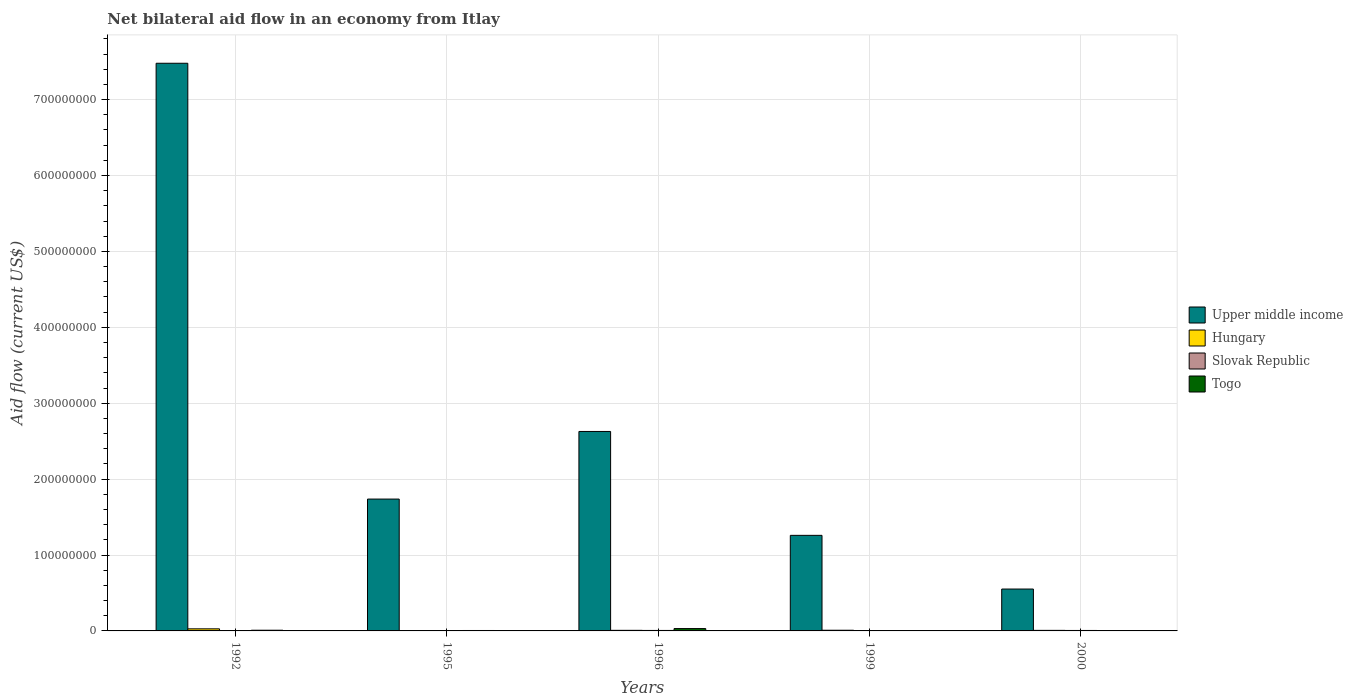How many different coloured bars are there?
Provide a succinct answer. 4. How many groups of bars are there?
Your response must be concise. 5. Are the number of bars per tick equal to the number of legend labels?
Provide a short and direct response. Yes. Are the number of bars on each tick of the X-axis equal?
Your response must be concise. Yes. How many bars are there on the 1st tick from the left?
Your answer should be compact. 4. How many bars are there on the 4th tick from the right?
Make the answer very short. 4. In how many cases, is the number of bars for a given year not equal to the number of legend labels?
Make the answer very short. 0. What is the net bilateral aid flow in Upper middle income in 2000?
Ensure brevity in your answer.  5.52e+07. Across all years, what is the maximum net bilateral aid flow in Slovak Republic?
Your answer should be compact. 6.30e+05. Across all years, what is the minimum net bilateral aid flow in Slovak Republic?
Make the answer very short. 2.50e+05. In which year was the net bilateral aid flow in Slovak Republic minimum?
Ensure brevity in your answer.  1995. What is the total net bilateral aid flow in Upper middle income in the graph?
Offer a very short reply. 1.37e+09. What is the difference between the net bilateral aid flow in Hungary in 1996 and that in 1999?
Ensure brevity in your answer.  -1.20e+05. What is the difference between the net bilateral aid flow in Togo in 1992 and the net bilateral aid flow in Hungary in 1999?
Give a very brief answer. 2.00e+04. What is the average net bilateral aid flow in Togo per year?
Make the answer very short. 9.20e+05. In how many years, is the net bilateral aid flow in Togo greater than 640000000 US$?
Your answer should be compact. 0. What is the ratio of the net bilateral aid flow in Upper middle income in 1996 to that in 1999?
Keep it short and to the point. 2.09. Is the net bilateral aid flow in Hungary in 1996 less than that in 2000?
Ensure brevity in your answer.  No. What is the difference between the highest and the lowest net bilateral aid flow in Togo?
Offer a terse response. 3.09e+06. In how many years, is the net bilateral aid flow in Togo greater than the average net bilateral aid flow in Togo taken over all years?
Make the answer very short. 1. Is it the case that in every year, the sum of the net bilateral aid flow in Togo and net bilateral aid flow in Hungary is greater than the sum of net bilateral aid flow in Slovak Republic and net bilateral aid flow in Upper middle income?
Offer a very short reply. No. What does the 2nd bar from the left in 1999 represents?
Your answer should be compact. Hungary. What does the 3rd bar from the right in 1999 represents?
Your response must be concise. Hungary. How many bars are there?
Make the answer very short. 20. How many years are there in the graph?
Your answer should be very brief. 5. Does the graph contain any zero values?
Keep it short and to the point. No. What is the title of the graph?
Provide a succinct answer. Net bilateral aid flow in an economy from Itlay. Does "Maldives" appear as one of the legend labels in the graph?
Your answer should be very brief. No. What is the label or title of the X-axis?
Provide a short and direct response. Years. What is the label or title of the Y-axis?
Give a very brief answer. Aid flow (current US$). What is the Aid flow (current US$) of Upper middle income in 1992?
Offer a terse response. 7.48e+08. What is the Aid flow (current US$) of Hungary in 1992?
Offer a very short reply. 2.74e+06. What is the Aid flow (current US$) of Slovak Republic in 1992?
Make the answer very short. 4.10e+05. What is the Aid flow (current US$) in Togo in 1992?
Give a very brief answer. 9.10e+05. What is the Aid flow (current US$) of Upper middle income in 1995?
Your answer should be very brief. 1.74e+08. What is the Aid flow (current US$) in Hungary in 1995?
Offer a very short reply. 3.30e+05. What is the Aid flow (current US$) of Togo in 1995?
Your answer should be compact. 5.70e+05. What is the Aid flow (current US$) in Upper middle income in 1996?
Provide a succinct answer. 2.63e+08. What is the Aid flow (current US$) of Hungary in 1996?
Your answer should be very brief. 7.70e+05. What is the Aid flow (current US$) of Slovak Republic in 1996?
Offer a very short reply. 6.30e+05. What is the Aid flow (current US$) in Togo in 1996?
Provide a succinct answer. 3.10e+06. What is the Aid flow (current US$) in Upper middle income in 1999?
Keep it short and to the point. 1.26e+08. What is the Aid flow (current US$) in Hungary in 1999?
Keep it short and to the point. 8.90e+05. What is the Aid flow (current US$) of Slovak Republic in 1999?
Ensure brevity in your answer.  2.60e+05. What is the Aid flow (current US$) in Upper middle income in 2000?
Provide a succinct answer. 5.52e+07. What is the Aid flow (current US$) in Hungary in 2000?
Ensure brevity in your answer.  7.20e+05. What is the Aid flow (current US$) of Slovak Republic in 2000?
Make the answer very short. 6.10e+05. Across all years, what is the maximum Aid flow (current US$) of Upper middle income?
Make the answer very short. 7.48e+08. Across all years, what is the maximum Aid flow (current US$) of Hungary?
Make the answer very short. 2.74e+06. Across all years, what is the maximum Aid flow (current US$) of Slovak Republic?
Your response must be concise. 6.30e+05. Across all years, what is the maximum Aid flow (current US$) in Togo?
Offer a very short reply. 3.10e+06. Across all years, what is the minimum Aid flow (current US$) of Upper middle income?
Ensure brevity in your answer.  5.52e+07. Across all years, what is the minimum Aid flow (current US$) of Hungary?
Ensure brevity in your answer.  3.30e+05. What is the total Aid flow (current US$) of Upper middle income in the graph?
Your answer should be compact. 1.37e+09. What is the total Aid flow (current US$) of Hungary in the graph?
Ensure brevity in your answer.  5.45e+06. What is the total Aid flow (current US$) of Slovak Republic in the graph?
Make the answer very short. 2.16e+06. What is the total Aid flow (current US$) of Togo in the graph?
Your answer should be very brief. 4.60e+06. What is the difference between the Aid flow (current US$) in Upper middle income in 1992 and that in 1995?
Your answer should be very brief. 5.74e+08. What is the difference between the Aid flow (current US$) in Hungary in 1992 and that in 1995?
Give a very brief answer. 2.41e+06. What is the difference between the Aid flow (current US$) of Slovak Republic in 1992 and that in 1995?
Make the answer very short. 1.60e+05. What is the difference between the Aid flow (current US$) of Togo in 1992 and that in 1995?
Your response must be concise. 3.40e+05. What is the difference between the Aid flow (current US$) of Upper middle income in 1992 and that in 1996?
Your answer should be compact. 4.85e+08. What is the difference between the Aid flow (current US$) of Hungary in 1992 and that in 1996?
Provide a succinct answer. 1.97e+06. What is the difference between the Aid flow (current US$) of Togo in 1992 and that in 1996?
Offer a very short reply. -2.19e+06. What is the difference between the Aid flow (current US$) in Upper middle income in 1992 and that in 1999?
Give a very brief answer. 6.22e+08. What is the difference between the Aid flow (current US$) of Hungary in 1992 and that in 1999?
Provide a succinct answer. 1.85e+06. What is the difference between the Aid flow (current US$) in Upper middle income in 1992 and that in 2000?
Your answer should be very brief. 6.93e+08. What is the difference between the Aid flow (current US$) in Hungary in 1992 and that in 2000?
Ensure brevity in your answer.  2.02e+06. What is the difference between the Aid flow (current US$) of Togo in 1992 and that in 2000?
Your response must be concise. 9.00e+05. What is the difference between the Aid flow (current US$) in Upper middle income in 1995 and that in 1996?
Your response must be concise. -8.91e+07. What is the difference between the Aid flow (current US$) of Hungary in 1995 and that in 1996?
Your answer should be compact. -4.40e+05. What is the difference between the Aid flow (current US$) of Slovak Republic in 1995 and that in 1996?
Ensure brevity in your answer.  -3.80e+05. What is the difference between the Aid flow (current US$) in Togo in 1995 and that in 1996?
Your response must be concise. -2.53e+06. What is the difference between the Aid flow (current US$) in Upper middle income in 1995 and that in 1999?
Your response must be concise. 4.78e+07. What is the difference between the Aid flow (current US$) of Hungary in 1995 and that in 1999?
Your response must be concise. -5.60e+05. What is the difference between the Aid flow (current US$) of Togo in 1995 and that in 1999?
Provide a succinct answer. 5.60e+05. What is the difference between the Aid flow (current US$) of Upper middle income in 1995 and that in 2000?
Provide a short and direct response. 1.19e+08. What is the difference between the Aid flow (current US$) of Hungary in 1995 and that in 2000?
Provide a succinct answer. -3.90e+05. What is the difference between the Aid flow (current US$) of Slovak Republic in 1995 and that in 2000?
Ensure brevity in your answer.  -3.60e+05. What is the difference between the Aid flow (current US$) in Togo in 1995 and that in 2000?
Ensure brevity in your answer.  5.60e+05. What is the difference between the Aid flow (current US$) of Upper middle income in 1996 and that in 1999?
Provide a succinct answer. 1.37e+08. What is the difference between the Aid flow (current US$) of Hungary in 1996 and that in 1999?
Ensure brevity in your answer.  -1.20e+05. What is the difference between the Aid flow (current US$) in Slovak Republic in 1996 and that in 1999?
Make the answer very short. 3.70e+05. What is the difference between the Aid flow (current US$) in Togo in 1996 and that in 1999?
Provide a succinct answer. 3.09e+06. What is the difference between the Aid flow (current US$) of Upper middle income in 1996 and that in 2000?
Your response must be concise. 2.08e+08. What is the difference between the Aid flow (current US$) in Hungary in 1996 and that in 2000?
Your answer should be compact. 5.00e+04. What is the difference between the Aid flow (current US$) of Slovak Republic in 1996 and that in 2000?
Your response must be concise. 2.00e+04. What is the difference between the Aid flow (current US$) of Togo in 1996 and that in 2000?
Your answer should be very brief. 3.09e+06. What is the difference between the Aid flow (current US$) of Upper middle income in 1999 and that in 2000?
Give a very brief answer. 7.07e+07. What is the difference between the Aid flow (current US$) in Slovak Republic in 1999 and that in 2000?
Offer a very short reply. -3.50e+05. What is the difference between the Aid flow (current US$) of Togo in 1999 and that in 2000?
Ensure brevity in your answer.  0. What is the difference between the Aid flow (current US$) of Upper middle income in 1992 and the Aid flow (current US$) of Hungary in 1995?
Ensure brevity in your answer.  7.48e+08. What is the difference between the Aid flow (current US$) in Upper middle income in 1992 and the Aid flow (current US$) in Slovak Republic in 1995?
Keep it short and to the point. 7.48e+08. What is the difference between the Aid flow (current US$) of Upper middle income in 1992 and the Aid flow (current US$) of Togo in 1995?
Offer a terse response. 7.47e+08. What is the difference between the Aid flow (current US$) in Hungary in 1992 and the Aid flow (current US$) in Slovak Republic in 1995?
Offer a very short reply. 2.49e+06. What is the difference between the Aid flow (current US$) in Hungary in 1992 and the Aid flow (current US$) in Togo in 1995?
Offer a very short reply. 2.17e+06. What is the difference between the Aid flow (current US$) of Upper middle income in 1992 and the Aid flow (current US$) of Hungary in 1996?
Make the answer very short. 7.47e+08. What is the difference between the Aid flow (current US$) of Upper middle income in 1992 and the Aid flow (current US$) of Slovak Republic in 1996?
Provide a short and direct response. 7.47e+08. What is the difference between the Aid flow (current US$) of Upper middle income in 1992 and the Aid flow (current US$) of Togo in 1996?
Offer a terse response. 7.45e+08. What is the difference between the Aid flow (current US$) in Hungary in 1992 and the Aid flow (current US$) in Slovak Republic in 1996?
Make the answer very short. 2.11e+06. What is the difference between the Aid flow (current US$) in Hungary in 1992 and the Aid flow (current US$) in Togo in 1996?
Ensure brevity in your answer.  -3.60e+05. What is the difference between the Aid flow (current US$) in Slovak Republic in 1992 and the Aid flow (current US$) in Togo in 1996?
Keep it short and to the point. -2.69e+06. What is the difference between the Aid flow (current US$) of Upper middle income in 1992 and the Aid flow (current US$) of Hungary in 1999?
Ensure brevity in your answer.  7.47e+08. What is the difference between the Aid flow (current US$) in Upper middle income in 1992 and the Aid flow (current US$) in Slovak Republic in 1999?
Make the answer very short. 7.48e+08. What is the difference between the Aid flow (current US$) of Upper middle income in 1992 and the Aid flow (current US$) of Togo in 1999?
Make the answer very short. 7.48e+08. What is the difference between the Aid flow (current US$) in Hungary in 1992 and the Aid flow (current US$) in Slovak Republic in 1999?
Offer a very short reply. 2.48e+06. What is the difference between the Aid flow (current US$) in Hungary in 1992 and the Aid flow (current US$) in Togo in 1999?
Your answer should be very brief. 2.73e+06. What is the difference between the Aid flow (current US$) in Upper middle income in 1992 and the Aid flow (current US$) in Hungary in 2000?
Ensure brevity in your answer.  7.47e+08. What is the difference between the Aid flow (current US$) in Upper middle income in 1992 and the Aid flow (current US$) in Slovak Republic in 2000?
Your answer should be compact. 7.47e+08. What is the difference between the Aid flow (current US$) in Upper middle income in 1992 and the Aid flow (current US$) in Togo in 2000?
Your answer should be compact. 7.48e+08. What is the difference between the Aid flow (current US$) of Hungary in 1992 and the Aid flow (current US$) of Slovak Republic in 2000?
Ensure brevity in your answer.  2.13e+06. What is the difference between the Aid flow (current US$) of Hungary in 1992 and the Aid flow (current US$) of Togo in 2000?
Ensure brevity in your answer.  2.73e+06. What is the difference between the Aid flow (current US$) of Slovak Republic in 1992 and the Aid flow (current US$) of Togo in 2000?
Make the answer very short. 4.00e+05. What is the difference between the Aid flow (current US$) of Upper middle income in 1995 and the Aid flow (current US$) of Hungary in 1996?
Make the answer very short. 1.73e+08. What is the difference between the Aid flow (current US$) of Upper middle income in 1995 and the Aid flow (current US$) of Slovak Republic in 1996?
Ensure brevity in your answer.  1.73e+08. What is the difference between the Aid flow (current US$) of Upper middle income in 1995 and the Aid flow (current US$) of Togo in 1996?
Make the answer very short. 1.71e+08. What is the difference between the Aid flow (current US$) in Hungary in 1995 and the Aid flow (current US$) in Slovak Republic in 1996?
Provide a succinct answer. -3.00e+05. What is the difference between the Aid flow (current US$) of Hungary in 1995 and the Aid flow (current US$) of Togo in 1996?
Give a very brief answer. -2.77e+06. What is the difference between the Aid flow (current US$) in Slovak Republic in 1995 and the Aid flow (current US$) in Togo in 1996?
Your answer should be compact. -2.85e+06. What is the difference between the Aid flow (current US$) in Upper middle income in 1995 and the Aid flow (current US$) in Hungary in 1999?
Keep it short and to the point. 1.73e+08. What is the difference between the Aid flow (current US$) of Upper middle income in 1995 and the Aid flow (current US$) of Slovak Republic in 1999?
Provide a succinct answer. 1.73e+08. What is the difference between the Aid flow (current US$) of Upper middle income in 1995 and the Aid flow (current US$) of Togo in 1999?
Offer a terse response. 1.74e+08. What is the difference between the Aid flow (current US$) in Upper middle income in 1995 and the Aid flow (current US$) in Hungary in 2000?
Offer a terse response. 1.73e+08. What is the difference between the Aid flow (current US$) in Upper middle income in 1995 and the Aid flow (current US$) in Slovak Republic in 2000?
Provide a succinct answer. 1.73e+08. What is the difference between the Aid flow (current US$) in Upper middle income in 1995 and the Aid flow (current US$) in Togo in 2000?
Your answer should be very brief. 1.74e+08. What is the difference between the Aid flow (current US$) of Hungary in 1995 and the Aid flow (current US$) of Slovak Republic in 2000?
Provide a short and direct response. -2.80e+05. What is the difference between the Aid flow (current US$) in Hungary in 1995 and the Aid flow (current US$) in Togo in 2000?
Keep it short and to the point. 3.20e+05. What is the difference between the Aid flow (current US$) in Slovak Republic in 1995 and the Aid flow (current US$) in Togo in 2000?
Keep it short and to the point. 2.40e+05. What is the difference between the Aid flow (current US$) of Upper middle income in 1996 and the Aid flow (current US$) of Hungary in 1999?
Your response must be concise. 2.62e+08. What is the difference between the Aid flow (current US$) of Upper middle income in 1996 and the Aid flow (current US$) of Slovak Republic in 1999?
Provide a short and direct response. 2.63e+08. What is the difference between the Aid flow (current US$) in Upper middle income in 1996 and the Aid flow (current US$) in Togo in 1999?
Provide a short and direct response. 2.63e+08. What is the difference between the Aid flow (current US$) in Hungary in 1996 and the Aid flow (current US$) in Slovak Republic in 1999?
Your answer should be very brief. 5.10e+05. What is the difference between the Aid flow (current US$) of Hungary in 1996 and the Aid flow (current US$) of Togo in 1999?
Provide a succinct answer. 7.60e+05. What is the difference between the Aid flow (current US$) in Slovak Republic in 1996 and the Aid flow (current US$) in Togo in 1999?
Give a very brief answer. 6.20e+05. What is the difference between the Aid flow (current US$) of Upper middle income in 1996 and the Aid flow (current US$) of Hungary in 2000?
Provide a short and direct response. 2.62e+08. What is the difference between the Aid flow (current US$) in Upper middle income in 1996 and the Aid flow (current US$) in Slovak Republic in 2000?
Offer a terse response. 2.62e+08. What is the difference between the Aid flow (current US$) of Upper middle income in 1996 and the Aid flow (current US$) of Togo in 2000?
Your answer should be compact. 2.63e+08. What is the difference between the Aid flow (current US$) in Hungary in 1996 and the Aid flow (current US$) in Togo in 2000?
Make the answer very short. 7.60e+05. What is the difference between the Aid flow (current US$) of Slovak Republic in 1996 and the Aid flow (current US$) of Togo in 2000?
Your response must be concise. 6.20e+05. What is the difference between the Aid flow (current US$) of Upper middle income in 1999 and the Aid flow (current US$) of Hungary in 2000?
Offer a very short reply. 1.25e+08. What is the difference between the Aid flow (current US$) in Upper middle income in 1999 and the Aid flow (current US$) in Slovak Republic in 2000?
Offer a terse response. 1.25e+08. What is the difference between the Aid flow (current US$) in Upper middle income in 1999 and the Aid flow (current US$) in Togo in 2000?
Make the answer very short. 1.26e+08. What is the difference between the Aid flow (current US$) of Hungary in 1999 and the Aid flow (current US$) of Togo in 2000?
Ensure brevity in your answer.  8.80e+05. What is the average Aid flow (current US$) in Upper middle income per year?
Keep it short and to the point. 2.73e+08. What is the average Aid flow (current US$) in Hungary per year?
Keep it short and to the point. 1.09e+06. What is the average Aid flow (current US$) of Slovak Republic per year?
Keep it short and to the point. 4.32e+05. What is the average Aid flow (current US$) in Togo per year?
Offer a very short reply. 9.20e+05. In the year 1992, what is the difference between the Aid flow (current US$) in Upper middle income and Aid flow (current US$) in Hungary?
Make the answer very short. 7.45e+08. In the year 1992, what is the difference between the Aid flow (current US$) in Upper middle income and Aid flow (current US$) in Slovak Republic?
Keep it short and to the point. 7.47e+08. In the year 1992, what is the difference between the Aid flow (current US$) in Upper middle income and Aid flow (current US$) in Togo?
Your answer should be compact. 7.47e+08. In the year 1992, what is the difference between the Aid flow (current US$) in Hungary and Aid flow (current US$) in Slovak Republic?
Provide a short and direct response. 2.33e+06. In the year 1992, what is the difference between the Aid flow (current US$) in Hungary and Aid flow (current US$) in Togo?
Ensure brevity in your answer.  1.83e+06. In the year 1992, what is the difference between the Aid flow (current US$) of Slovak Republic and Aid flow (current US$) of Togo?
Offer a terse response. -5.00e+05. In the year 1995, what is the difference between the Aid flow (current US$) of Upper middle income and Aid flow (current US$) of Hungary?
Make the answer very short. 1.73e+08. In the year 1995, what is the difference between the Aid flow (current US$) in Upper middle income and Aid flow (current US$) in Slovak Republic?
Ensure brevity in your answer.  1.73e+08. In the year 1995, what is the difference between the Aid flow (current US$) of Upper middle income and Aid flow (current US$) of Togo?
Keep it short and to the point. 1.73e+08. In the year 1995, what is the difference between the Aid flow (current US$) in Slovak Republic and Aid flow (current US$) in Togo?
Your response must be concise. -3.20e+05. In the year 1996, what is the difference between the Aid flow (current US$) in Upper middle income and Aid flow (current US$) in Hungary?
Keep it short and to the point. 2.62e+08. In the year 1996, what is the difference between the Aid flow (current US$) of Upper middle income and Aid flow (current US$) of Slovak Republic?
Provide a short and direct response. 2.62e+08. In the year 1996, what is the difference between the Aid flow (current US$) in Upper middle income and Aid flow (current US$) in Togo?
Your answer should be compact. 2.60e+08. In the year 1996, what is the difference between the Aid flow (current US$) of Hungary and Aid flow (current US$) of Slovak Republic?
Offer a terse response. 1.40e+05. In the year 1996, what is the difference between the Aid flow (current US$) of Hungary and Aid flow (current US$) of Togo?
Make the answer very short. -2.33e+06. In the year 1996, what is the difference between the Aid flow (current US$) in Slovak Republic and Aid flow (current US$) in Togo?
Offer a terse response. -2.47e+06. In the year 1999, what is the difference between the Aid flow (current US$) of Upper middle income and Aid flow (current US$) of Hungary?
Keep it short and to the point. 1.25e+08. In the year 1999, what is the difference between the Aid flow (current US$) in Upper middle income and Aid flow (current US$) in Slovak Republic?
Offer a very short reply. 1.26e+08. In the year 1999, what is the difference between the Aid flow (current US$) of Upper middle income and Aid flow (current US$) of Togo?
Your response must be concise. 1.26e+08. In the year 1999, what is the difference between the Aid flow (current US$) in Hungary and Aid flow (current US$) in Slovak Republic?
Give a very brief answer. 6.30e+05. In the year 1999, what is the difference between the Aid flow (current US$) in Hungary and Aid flow (current US$) in Togo?
Ensure brevity in your answer.  8.80e+05. In the year 1999, what is the difference between the Aid flow (current US$) in Slovak Republic and Aid flow (current US$) in Togo?
Provide a short and direct response. 2.50e+05. In the year 2000, what is the difference between the Aid flow (current US$) in Upper middle income and Aid flow (current US$) in Hungary?
Offer a very short reply. 5.44e+07. In the year 2000, what is the difference between the Aid flow (current US$) of Upper middle income and Aid flow (current US$) of Slovak Republic?
Offer a terse response. 5.46e+07. In the year 2000, what is the difference between the Aid flow (current US$) of Upper middle income and Aid flow (current US$) of Togo?
Your answer should be very brief. 5.52e+07. In the year 2000, what is the difference between the Aid flow (current US$) in Hungary and Aid flow (current US$) in Togo?
Your answer should be very brief. 7.10e+05. What is the ratio of the Aid flow (current US$) of Upper middle income in 1992 to that in 1995?
Provide a short and direct response. 4.31. What is the ratio of the Aid flow (current US$) in Hungary in 1992 to that in 1995?
Your answer should be very brief. 8.3. What is the ratio of the Aid flow (current US$) of Slovak Republic in 1992 to that in 1995?
Offer a terse response. 1.64. What is the ratio of the Aid flow (current US$) of Togo in 1992 to that in 1995?
Make the answer very short. 1.6. What is the ratio of the Aid flow (current US$) in Upper middle income in 1992 to that in 1996?
Give a very brief answer. 2.85. What is the ratio of the Aid flow (current US$) in Hungary in 1992 to that in 1996?
Ensure brevity in your answer.  3.56. What is the ratio of the Aid flow (current US$) in Slovak Republic in 1992 to that in 1996?
Give a very brief answer. 0.65. What is the ratio of the Aid flow (current US$) in Togo in 1992 to that in 1996?
Your answer should be compact. 0.29. What is the ratio of the Aid flow (current US$) of Upper middle income in 1992 to that in 1999?
Make the answer very short. 5.94. What is the ratio of the Aid flow (current US$) in Hungary in 1992 to that in 1999?
Provide a succinct answer. 3.08. What is the ratio of the Aid flow (current US$) in Slovak Republic in 1992 to that in 1999?
Your answer should be compact. 1.58. What is the ratio of the Aid flow (current US$) in Togo in 1992 to that in 1999?
Your answer should be compact. 91. What is the ratio of the Aid flow (current US$) of Upper middle income in 1992 to that in 2000?
Ensure brevity in your answer.  13.56. What is the ratio of the Aid flow (current US$) of Hungary in 1992 to that in 2000?
Provide a short and direct response. 3.81. What is the ratio of the Aid flow (current US$) in Slovak Republic in 1992 to that in 2000?
Provide a succinct answer. 0.67. What is the ratio of the Aid flow (current US$) in Togo in 1992 to that in 2000?
Provide a short and direct response. 91. What is the ratio of the Aid flow (current US$) in Upper middle income in 1995 to that in 1996?
Give a very brief answer. 0.66. What is the ratio of the Aid flow (current US$) in Hungary in 1995 to that in 1996?
Your answer should be compact. 0.43. What is the ratio of the Aid flow (current US$) of Slovak Republic in 1995 to that in 1996?
Keep it short and to the point. 0.4. What is the ratio of the Aid flow (current US$) of Togo in 1995 to that in 1996?
Your response must be concise. 0.18. What is the ratio of the Aid flow (current US$) in Upper middle income in 1995 to that in 1999?
Provide a short and direct response. 1.38. What is the ratio of the Aid flow (current US$) in Hungary in 1995 to that in 1999?
Give a very brief answer. 0.37. What is the ratio of the Aid flow (current US$) of Slovak Republic in 1995 to that in 1999?
Offer a very short reply. 0.96. What is the ratio of the Aid flow (current US$) in Upper middle income in 1995 to that in 2000?
Keep it short and to the point. 3.15. What is the ratio of the Aid flow (current US$) in Hungary in 1995 to that in 2000?
Your answer should be compact. 0.46. What is the ratio of the Aid flow (current US$) of Slovak Republic in 1995 to that in 2000?
Keep it short and to the point. 0.41. What is the ratio of the Aid flow (current US$) in Upper middle income in 1996 to that in 1999?
Offer a terse response. 2.09. What is the ratio of the Aid flow (current US$) in Hungary in 1996 to that in 1999?
Keep it short and to the point. 0.87. What is the ratio of the Aid flow (current US$) of Slovak Republic in 1996 to that in 1999?
Your response must be concise. 2.42. What is the ratio of the Aid flow (current US$) in Togo in 1996 to that in 1999?
Ensure brevity in your answer.  310. What is the ratio of the Aid flow (current US$) of Upper middle income in 1996 to that in 2000?
Your response must be concise. 4.76. What is the ratio of the Aid flow (current US$) of Hungary in 1996 to that in 2000?
Give a very brief answer. 1.07. What is the ratio of the Aid flow (current US$) of Slovak Republic in 1996 to that in 2000?
Offer a terse response. 1.03. What is the ratio of the Aid flow (current US$) in Togo in 1996 to that in 2000?
Provide a succinct answer. 310. What is the ratio of the Aid flow (current US$) of Upper middle income in 1999 to that in 2000?
Provide a short and direct response. 2.28. What is the ratio of the Aid flow (current US$) of Hungary in 1999 to that in 2000?
Your answer should be compact. 1.24. What is the ratio of the Aid flow (current US$) in Slovak Republic in 1999 to that in 2000?
Offer a very short reply. 0.43. What is the ratio of the Aid flow (current US$) of Togo in 1999 to that in 2000?
Provide a short and direct response. 1. What is the difference between the highest and the second highest Aid flow (current US$) in Upper middle income?
Provide a succinct answer. 4.85e+08. What is the difference between the highest and the second highest Aid flow (current US$) in Hungary?
Ensure brevity in your answer.  1.85e+06. What is the difference between the highest and the second highest Aid flow (current US$) in Slovak Republic?
Ensure brevity in your answer.  2.00e+04. What is the difference between the highest and the second highest Aid flow (current US$) of Togo?
Keep it short and to the point. 2.19e+06. What is the difference between the highest and the lowest Aid flow (current US$) of Upper middle income?
Make the answer very short. 6.93e+08. What is the difference between the highest and the lowest Aid flow (current US$) in Hungary?
Your answer should be compact. 2.41e+06. What is the difference between the highest and the lowest Aid flow (current US$) in Slovak Republic?
Ensure brevity in your answer.  3.80e+05. What is the difference between the highest and the lowest Aid flow (current US$) in Togo?
Provide a short and direct response. 3.09e+06. 